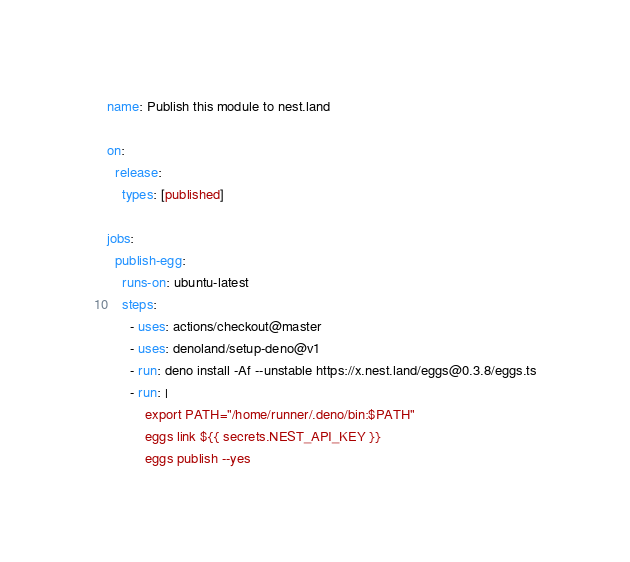<code> <loc_0><loc_0><loc_500><loc_500><_YAML_>name: Publish this module to nest.land

on:
  release:
    types: [published]

jobs:
  publish-egg:
    runs-on: ubuntu-latest
    steps:
      - uses: actions/checkout@master
      - uses: denoland/setup-deno@v1
      - run: deno install -Af --unstable https://x.nest.land/eggs@0.3.8/eggs.ts
      - run: |
          export PATH="/home/runner/.deno/bin:$PATH"
          eggs link ${{ secrets.NEST_API_KEY }}
          eggs publish --yes
</code> 